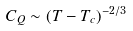<formula> <loc_0><loc_0><loc_500><loc_500>C _ { Q } \sim ( T - T _ { c } ) ^ { - 2 / 3 }</formula> 